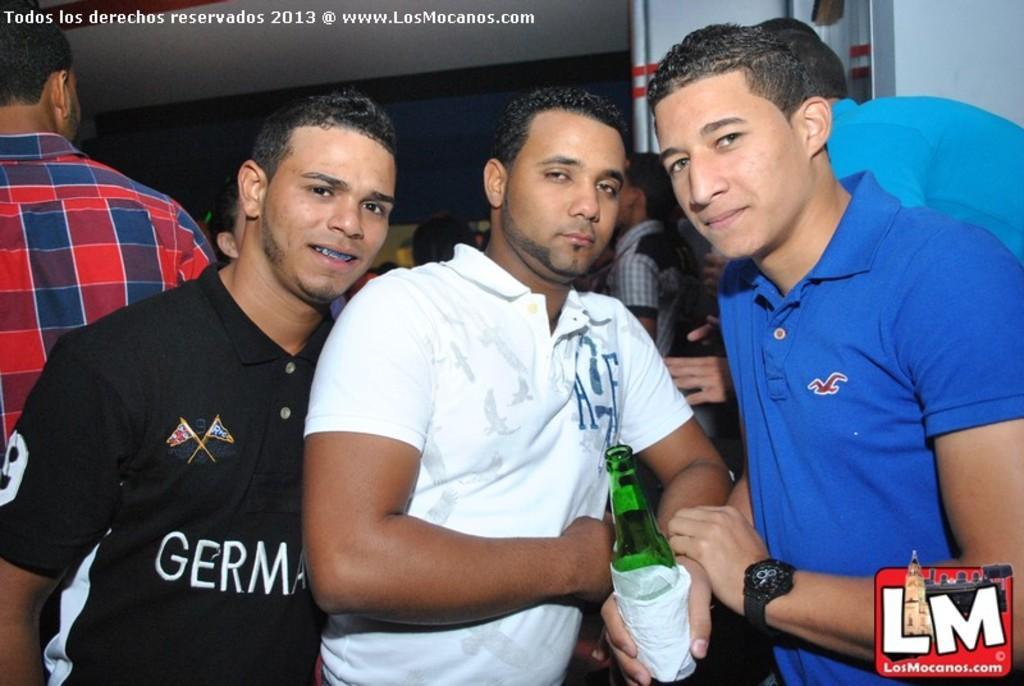Please provide a concise description of this image. In this image I can see three men are standing. This man is holding a green color bottle and tissues in the hand. Here I can see watermarks. In the background, I can see people, a wall and something over here. 